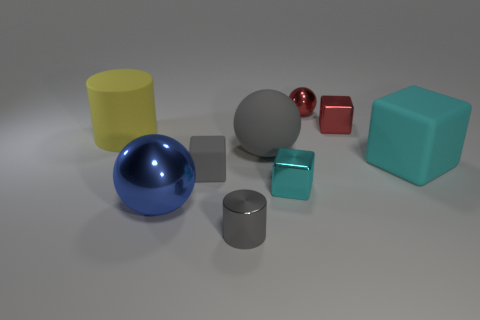Can you tell me about the different textures visible in the image? Certainly! The image displays objects with mostly smooth and shiny textures, with varying degrees of reflectiveness. The silver cylinder, sphere, and cube have highly reflective, smooth surfaces, while the yellow cylinder, red cube, and blue sphere appear to have a slightly matte finish. 